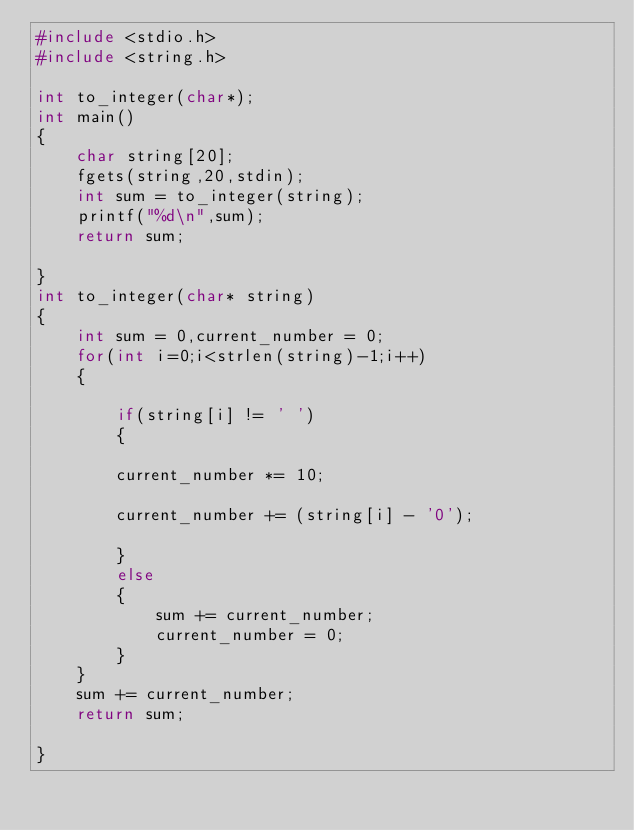<code> <loc_0><loc_0><loc_500><loc_500><_C_>#include <stdio.h>
#include <string.h>

int to_integer(char*);
int main()
{
    char string[20];
    fgets(string,20,stdin);
    int sum = to_integer(string);
    printf("%d\n",sum);
    return sum;
    
}
int to_integer(char* string)
{   
    int sum = 0,current_number = 0;
    for(int i=0;i<strlen(string)-1;i++)
    {
        
        if(string[i] != ' ')
        {
        
        current_number *= 10;
        
        current_number += (string[i] - '0');
        
        }
        else
        {
            sum += current_number;
            current_number = 0;
        }
    }
    sum += current_number;
    return sum;
    
}

</code> 